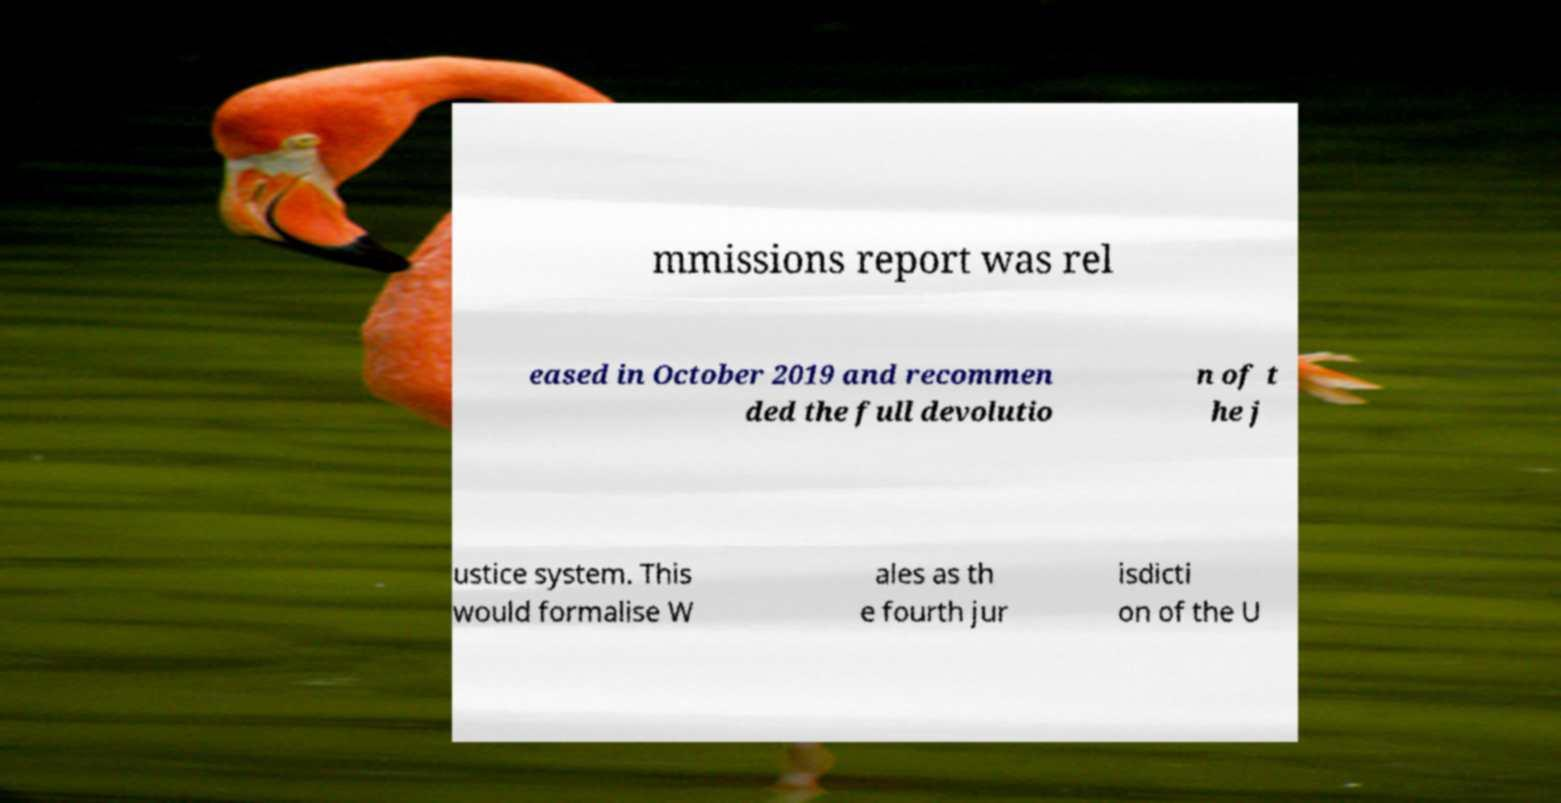Can you read and provide the text displayed in the image?This photo seems to have some interesting text. Can you extract and type it out for me? mmissions report was rel eased in October 2019 and recommen ded the full devolutio n of t he j ustice system. This would formalise W ales as th e fourth jur isdicti on of the U 